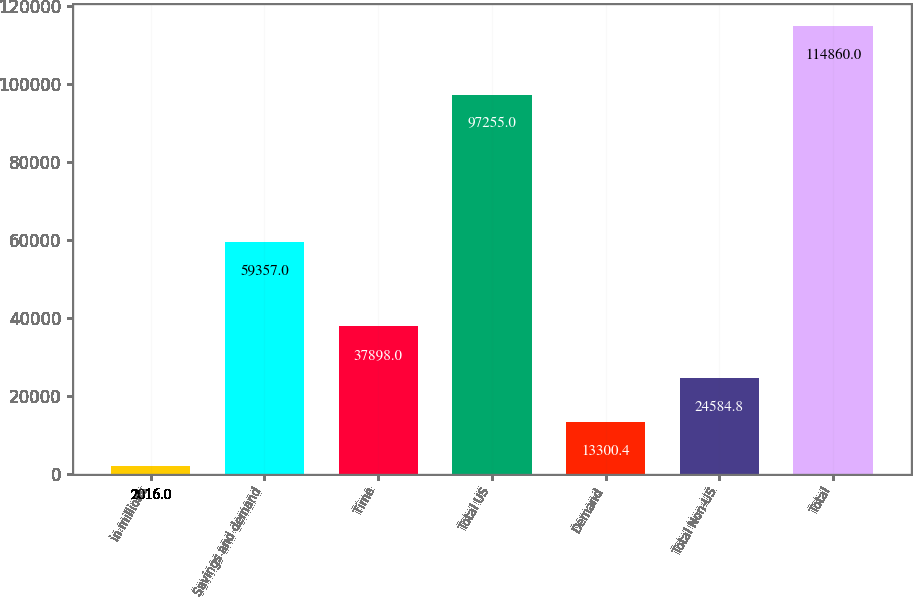Convert chart to OTSL. <chart><loc_0><loc_0><loc_500><loc_500><bar_chart><fcel>in millions<fcel>Savings and demand<fcel>Time<fcel>Total US<fcel>Demand<fcel>Total Non-US<fcel>Total<nl><fcel>2016<fcel>59357<fcel>37898<fcel>97255<fcel>13300.4<fcel>24584.8<fcel>114860<nl></chart> 